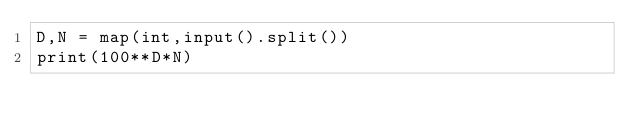Convert code to text. <code><loc_0><loc_0><loc_500><loc_500><_Python_>D,N = map(int,input().split())
print(100**D*N)
</code> 